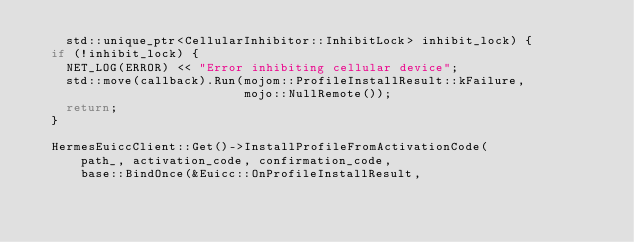<code> <loc_0><loc_0><loc_500><loc_500><_C++_>    std::unique_ptr<CellularInhibitor::InhibitLock> inhibit_lock) {
  if (!inhibit_lock) {
    NET_LOG(ERROR) << "Error inhibiting cellular device";
    std::move(callback).Run(mojom::ProfileInstallResult::kFailure,
                            mojo::NullRemote());
    return;
  }

  HermesEuiccClient::Get()->InstallProfileFromActivationCode(
      path_, activation_code, confirmation_code,
      base::BindOnce(&Euicc::OnProfileInstallResult,</code> 